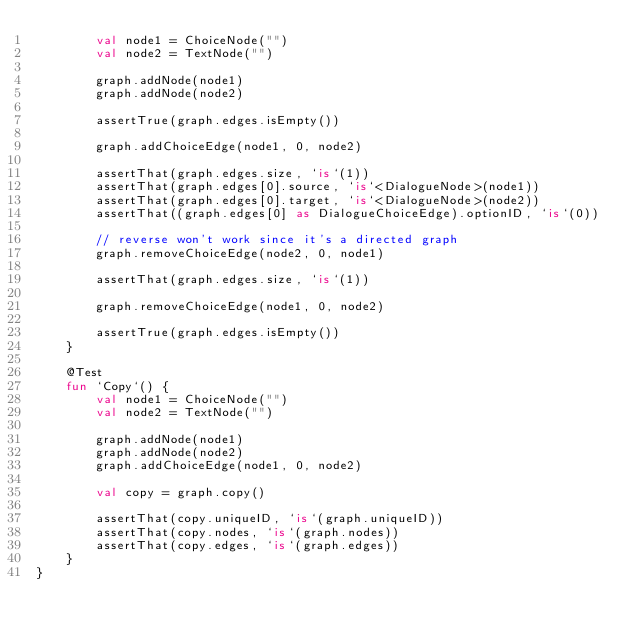<code> <loc_0><loc_0><loc_500><loc_500><_Kotlin_>        val node1 = ChoiceNode("")
        val node2 = TextNode("")

        graph.addNode(node1)
        graph.addNode(node2)

        assertTrue(graph.edges.isEmpty())

        graph.addChoiceEdge(node1, 0, node2)

        assertThat(graph.edges.size, `is`(1))
        assertThat(graph.edges[0].source, `is`<DialogueNode>(node1))
        assertThat(graph.edges[0].target, `is`<DialogueNode>(node2))
        assertThat((graph.edges[0] as DialogueChoiceEdge).optionID, `is`(0))

        // reverse won't work since it's a directed graph
        graph.removeChoiceEdge(node2, 0, node1)

        assertThat(graph.edges.size, `is`(1))

        graph.removeChoiceEdge(node1, 0, node2)

        assertTrue(graph.edges.isEmpty())
    }

    @Test
    fun `Copy`() {
        val node1 = ChoiceNode("")
        val node2 = TextNode("")

        graph.addNode(node1)
        graph.addNode(node2)
        graph.addChoiceEdge(node1, 0, node2)

        val copy = graph.copy()

        assertThat(copy.uniqueID, `is`(graph.uniqueID))
        assertThat(copy.nodes, `is`(graph.nodes))
        assertThat(copy.edges, `is`(graph.edges))
    }
}</code> 